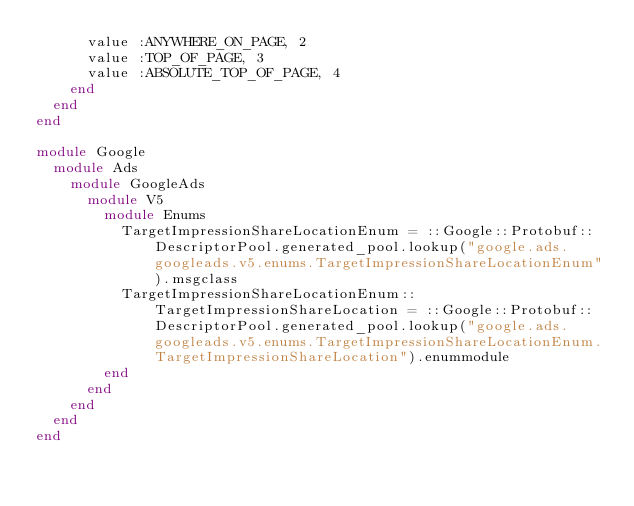Convert code to text. <code><loc_0><loc_0><loc_500><loc_500><_Ruby_>      value :ANYWHERE_ON_PAGE, 2
      value :TOP_OF_PAGE, 3
      value :ABSOLUTE_TOP_OF_PAGE, 4
    end
  end
end

module Google
  module Ads
    module GoogleAds
      module V5
        module Enums
          TargetImpressionShareLocationEnum = ::Google::Protobuf::DescriptorPool.generated_pool.lookup("google.ads.googleads.v5.enums.TargetImpressionShareLocationEnum").msgclass
          TargetImpressionShareLocationEnum::TargetImpressionShareLocation = ::Google::Protobuf::DescriptorPool.generated_pool.lookup("google.ads.googleads.v5.enums.TargetImpressionShareLocationEnum.TargetImpressionShareLocation").enummodule
        end
      end
    end
  end
end
</code> 